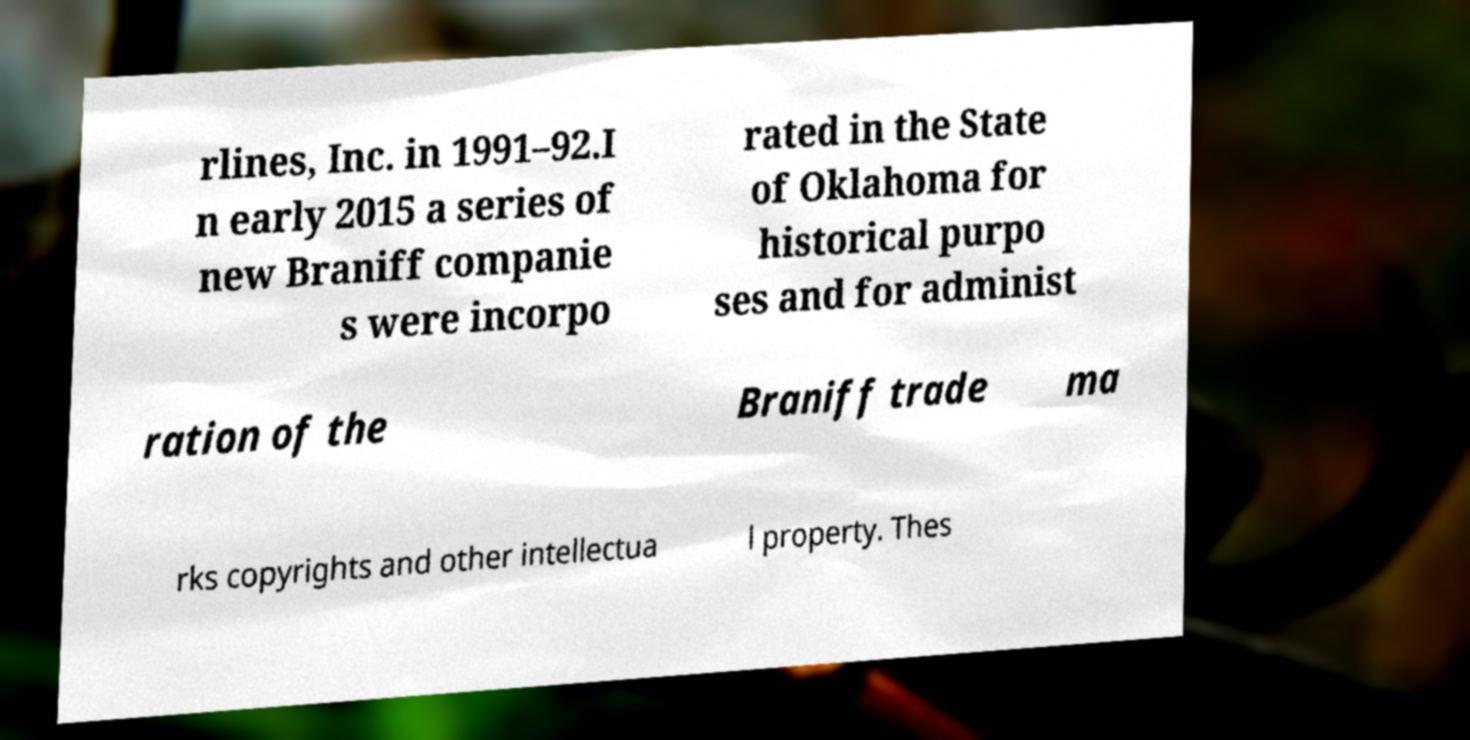Could you extract and type out the text from this image? rlines, Inc. in 1991–92.I n early 2015 a series of new Braniff companie s were incorpo rated in the State of Oklahoma for historical purpo ses and for administ ration of the Braniff trade ma rks copyrights and other intellectua l property. Thes 